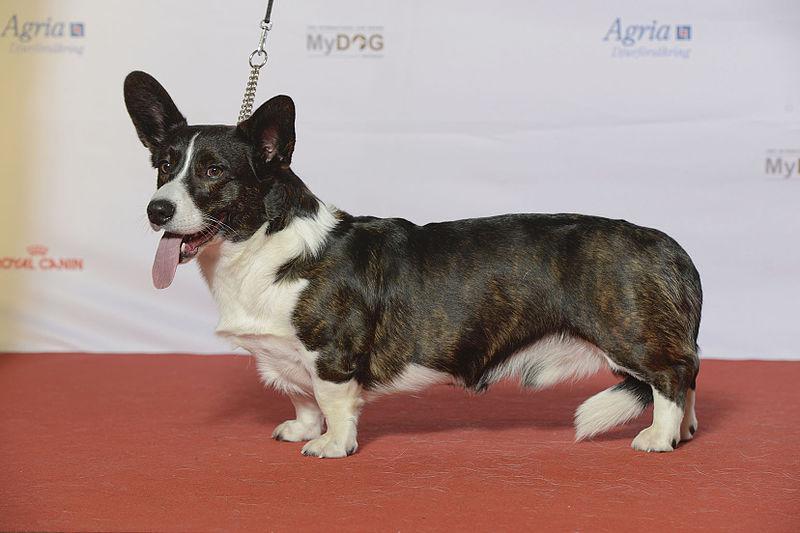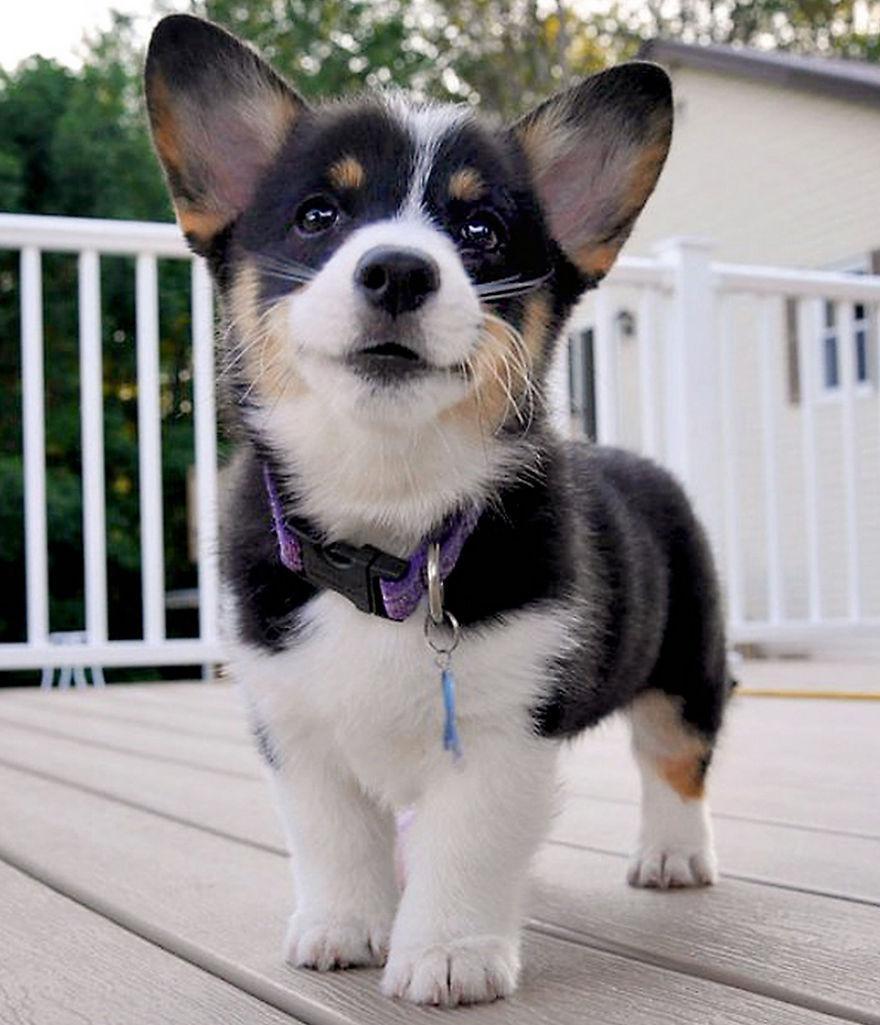The first image is the image on the left, the second image is the image on the right. Considering the images on both sides, is "At least one dog's tongue is hanging out of its mouth." valid? Answer yes or no. Yes. The first image is the image on the left, the second image is the image on the right. Given the left and right images, does the statement "An image shows a corgi dog without a leash, standing on all fours and looking upward at the camera." hold true? Answer yes or no. Yes. 